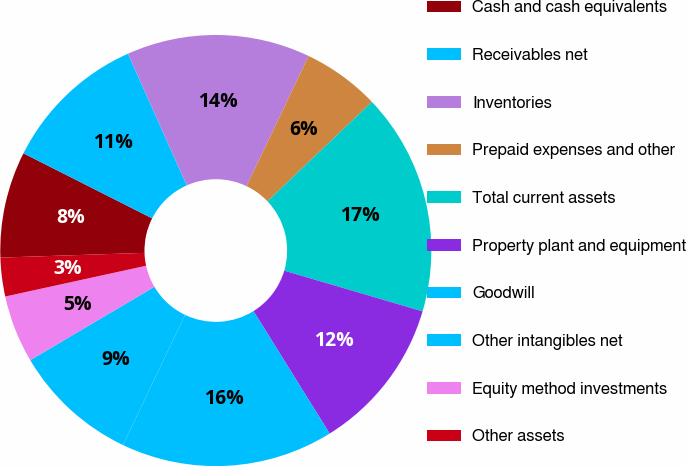<chart> <loc_0><loc_0><loc_500><loc_500><pie_chart><fcel>Cash and cash equivalents<fcel>Receivables net<fcel>Inventories<fcel>Prepaid expenses and other<fcel>Total current assets<fcel>Property plant and equipment<fcel>Goodwill<fcel>Other intangibles net<fcel>Equity method investments<fcel>Other assets<nl><fcel>7.97%<fcel>10.87%<fcel>13.77%<fcel>5.8%<fcel>16.67%<fcel>11.59%<fcel>15.94%<fcel>9.42%<fcel>5.07%<fcel>2.9%<nl></chart> 